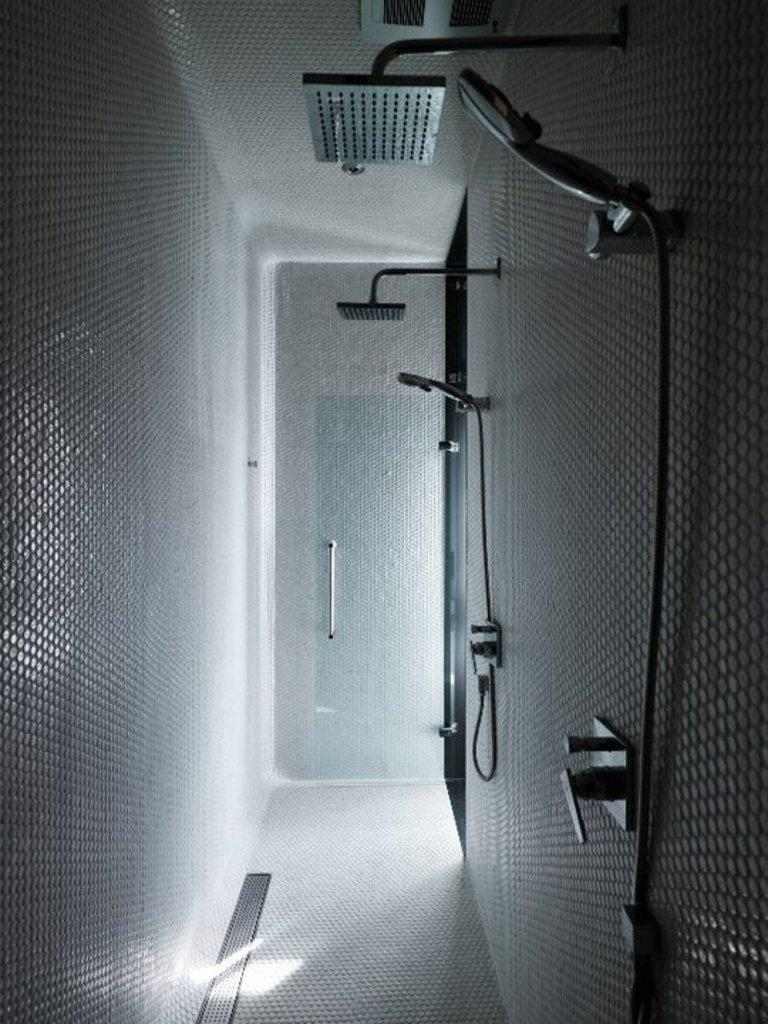What type of room is shown in the image? The image depicts a washroom. What feature can be found in the washroom? There are showers in the washroom. Is there any specific architectural element in the washroom? Yes, there is a glass door in the washroom. What type of plants can be seen growing on the canvas in the image? There is no canvas or plants present in the image; it depicts a washroom with showers and a glass door. 